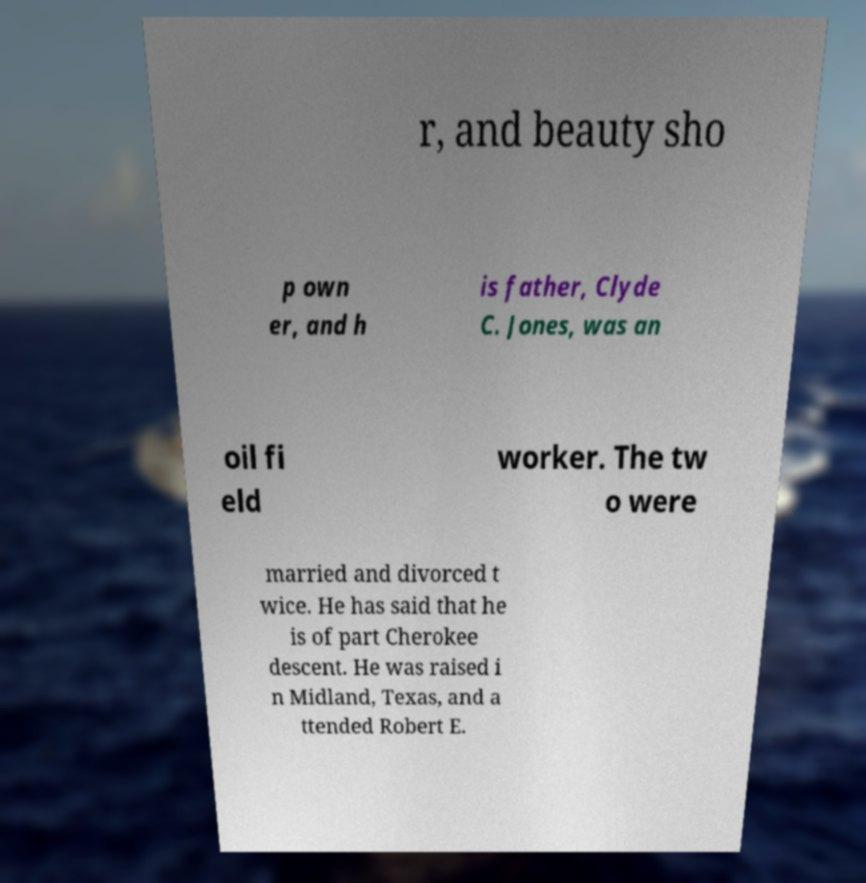Please read and relay the text visible in this image. What does it say? r, and beauty sho p own er, and h is father, Clyde C. Jones, was an oil fi eld worker. The tw o were married and divorced t wice. He has said that he is of part Cherokee descent. He was raised i n Midland, Texas, and a ttended Robert E. 